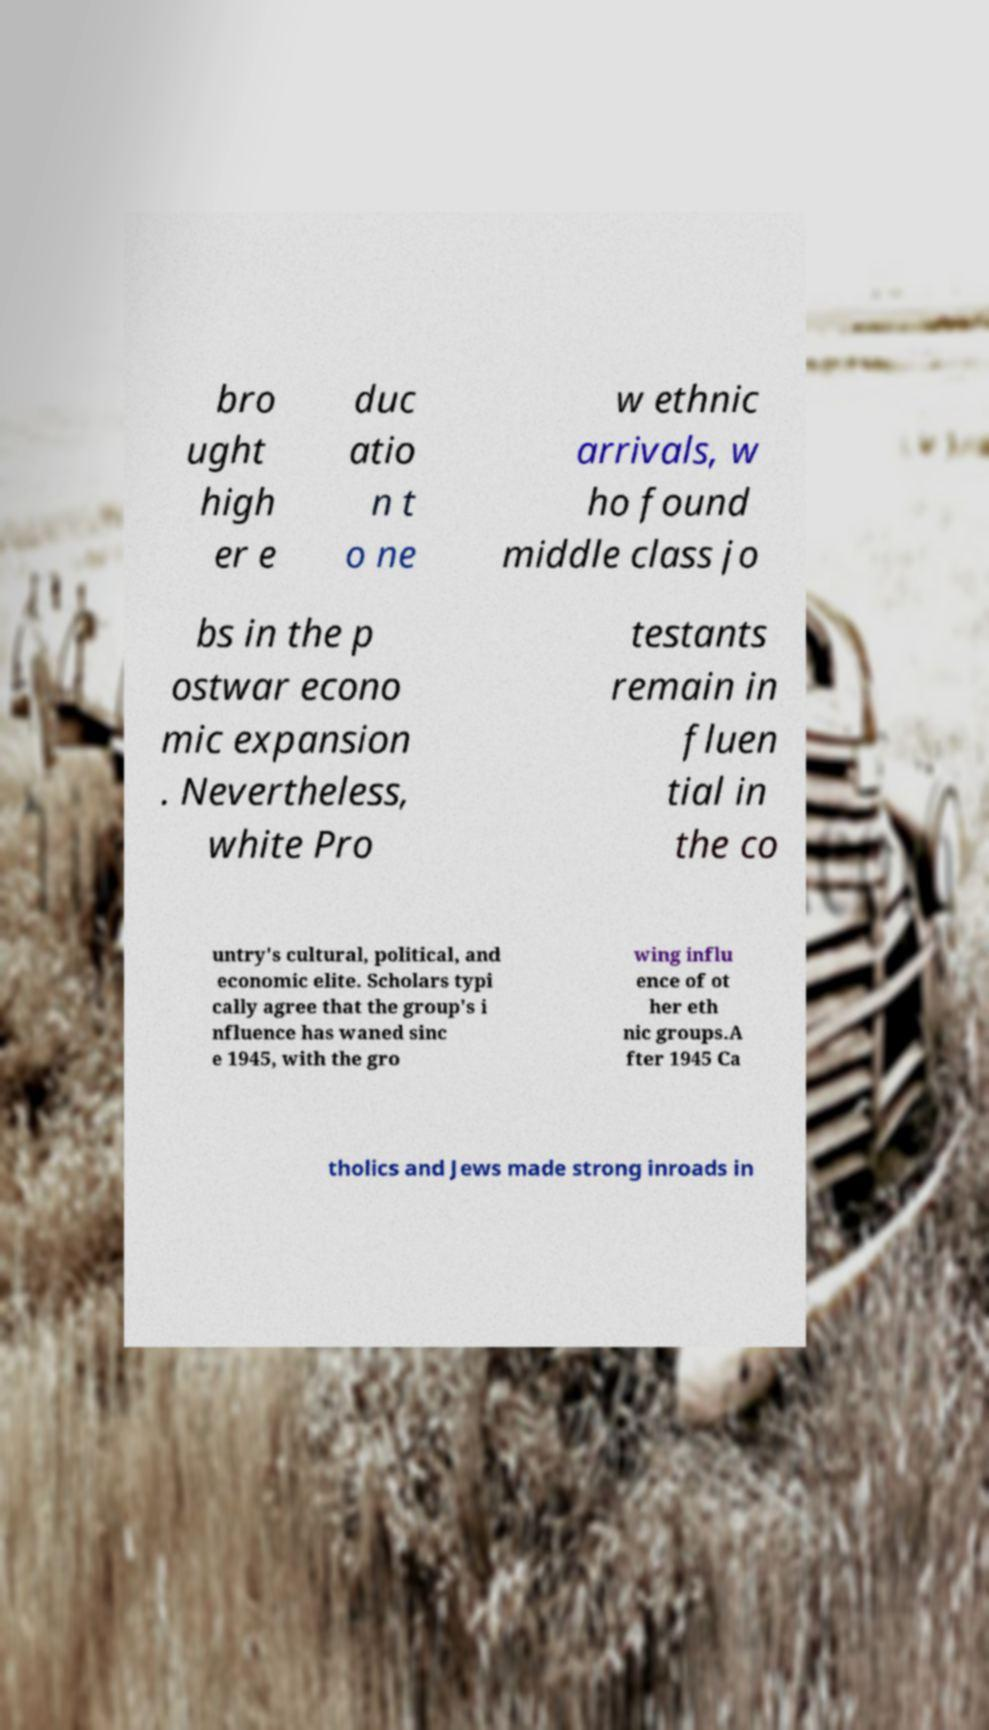What messages or text are displayed in this image? I need them in a readable, typed format. bro ught high er e duc atio n t o ne w ethnic arrivals, w ho found middle class jo bs in the p ostwar econo mic expansion . Nevertheless, white Pro testants remain in fluen tial in the co untry's cultural, political, and economic elite. Scholars typi cally agree that the group's i nfluence has waned sinc e 1945, with the gro wing influ ence of ot her eth nic groups.A fter 1945 Ca tholics and Jews made strong inroads in 